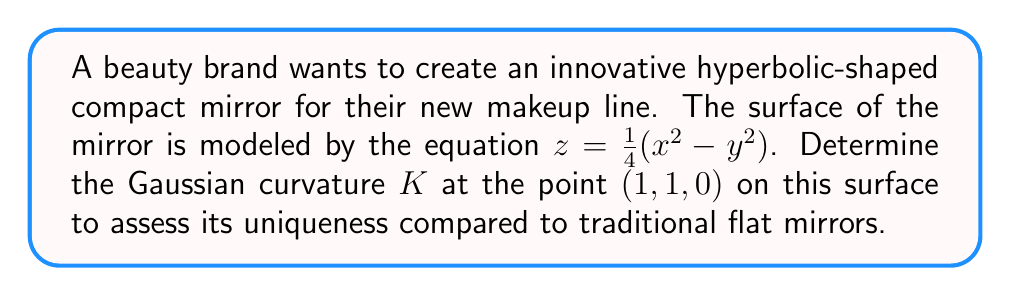Give your solution to this math problem. To find the Gaussian curvature $K$ of the hyperbolic surface at the point $(1, 1, 0)$, we'll follow these steps:

1) The surface is given by $z = \frac{1}{4}(x^2 - y^2)$. Let's define $f(x,y) = \frac{1}{4}(x^2 - y^2)$.

2) Calculate the first and second partial derivatives:
   $f_x = \frac{1}{2}x$, $f_y = -\frac{1}{2}y$
   $f_{xx} = \frac{1}{2}$, $f_{yy} = -\frac{1}{2}$, $f_{xy} = f_{yx} = 0$

3) The Gaussian curvature $K$ is given by:
   $$K = \frac{f_{xx}f_{yy} - f_{xy}^2}{(1 + f_x^2 + f_y^2)^2}$$

4) At the point $(1, 1, 0)$:
   $f_x = \frac{1}{2}$, $f_y = -\frac{1}{2}$
   $f_{xx} = \frac{1}{2}$, $f_{yy} = -\frac{1}{2}$, $f_{xy} = 0$

5) Substituting these values into the formula:
   $$K = \frac{(\frac{1}{2})(-\frac{1}{2}) - 0^2}{(1 + (\frac{1}{2})^2 + (-\frac{1}{2})^2)^2}$$

6) Simplify:
   $$K = \frac{-\frac{1}{4}}{(1 + \frac{1}{4} + \frac{1}{4})^2} = \frac{-\frac{1}{4}}{(\frac{3}{2})^2} = \frac{-\frac{1}{4}}{\frac{9}{4}} = -\frac{1}{9}$$

Therefore, the Gaussian curvature $K$ at the point $(1, 1, 0)$ is $-\frac{1}{9}$.
Answer: $K = -\frac{1}{9}$ 